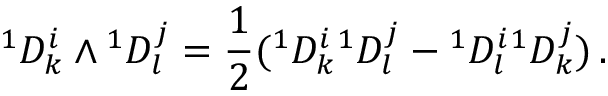Convert formula to latex. <formula><loc_0><loc_0><loc_500><loc_500>{ } ^ { 1 } D _ { k } ^ { i } ^ { 1 } D _ { l } ^ { j } = \frac { 1 } { 2 } ^ { 1 } D _ { k } ^ { i ^ { 1 } D _ { l } ^ { j } ^ { 1 } D _ { l } ^ { i ^ { 1 } D _ { k } ^ { j } ) \, .</formula> 